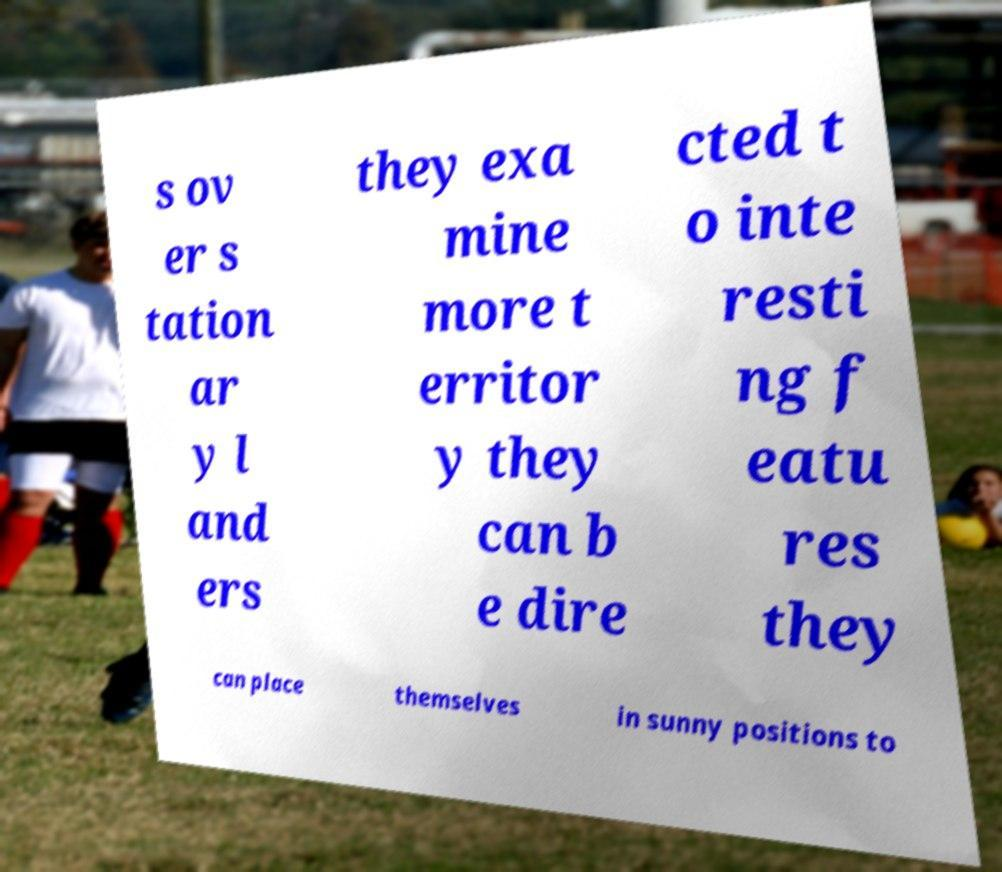Can you read and provide the text displayed in the image?This photo seems to have some interesting text. Can you extract and type it out for me? s ov er s tation ar y l and ers they exa mine more t erritor y they can b e dire cted t o inte resti ng f eatu res they can place themselves in sunny positions to 